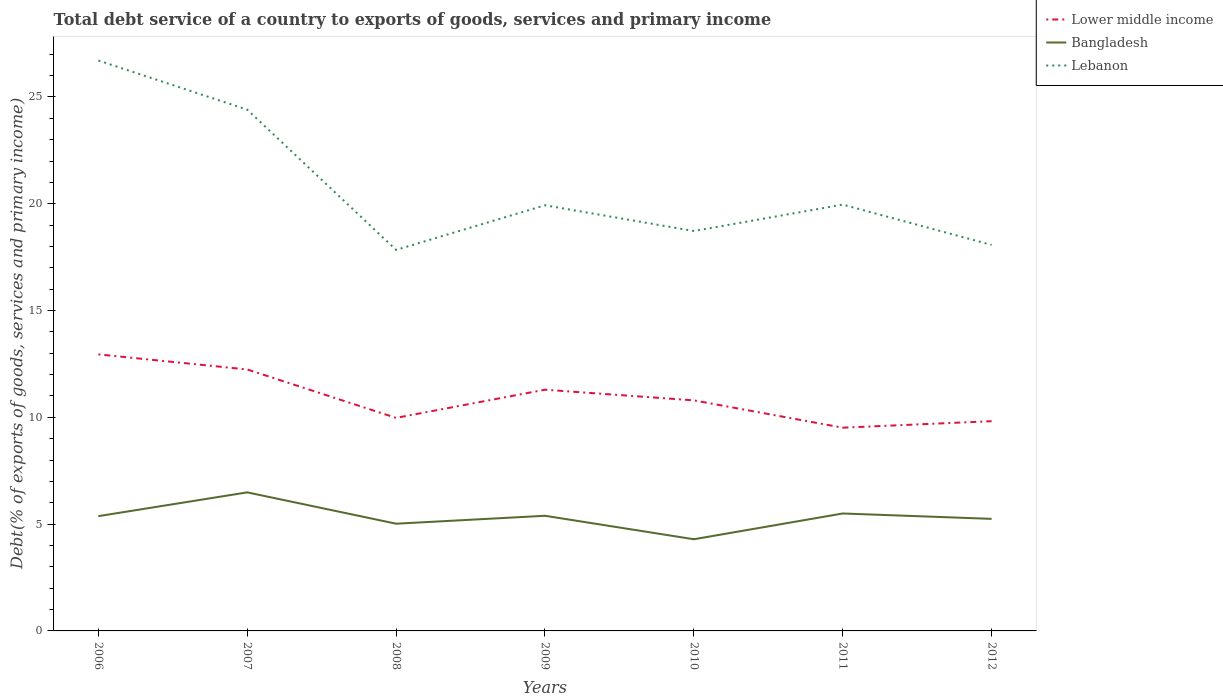Across all years, what is the maximum total debt service in Lebanon?
Make the answer very short. 17.84. In which year was the total debt service in Bangladesh maximum?
Make the answer very short. 2010. What is the total total debt service in Bangladesh in the graph?
Ensure brevity in your answer.  -0.02. What is the difference between the highest and the second highest total debt service in Lower middle income?
Your answer should be very brief. 3.43. Is the total debt service in Bangladesh strictly greater than the total debt service in Lebanon over the years?
Keep it short and to the point. Yes. How many lines are there?
Ensure brevity in your answer.  3. How many years are there in the graph?
Ensure brevity in your answer.  7. Are the values on the major ticks of Y-axis written in scientific E-notation?
Offer a terse response. No. Does the graph contain any zero values?
Offer a terse response. No. Where does the legend appear in the graph?
Your answer should be very brief. Top right. How many legend labels are there?
Make the answer very short. 3. How are the legend labels stacked?
Ensure brevity in your answer.  Vertical. What is the title of the graph?
Keep it short and to the point. Total debt service of a country to exports of goods, services and primary income. What is the label or title of the X-axis?
Your response must be concise. Years. What is the label or title of the Y-axis?
Provide a short and direct response. Debt(% of exports of goods, services and primary income). What is the Debt(% of exports of goods, services and primary income) of Lower middle income in 2006?
Offer a very short reply. 12.95. What is the Debt(% of exports of goods, services and primary income) of Bangladesh in 2006?
Your answer should be very brief. 5.37. What is the Debt(% of exports of goods, services and primary income) in Lebanon in 2006?
Give a very brief answer. 26.71. What is the Debt(% of exports of goods, services and primary income) of Lower middle income in 2007?
Your answer should be very brief. 12.24. What is the Debt(% of exports of goods, services and primary income) of Bangladesh in 2007?
Provide a short and direct response. 6.49. What is the Debt(% of exports of goods, services and primary income) in Lebanon in 2007?
Provide a short and direct response. 24.41. What is the Debt(% of exports of goods, services and primary income) of Lower middle income in 2008?
Ensure brevity in your answer.  9.98. What is the Debt(% of exports of goods, services and primary income) of Bangladesh in 2008?
Your answer should be compact. 5.02. What is the Debt(% of exports of goods, services and primary income) in Lebanon in 2008?
Your response must be concise. 17.84. What is the Debt(% of exports of goods, services and primary income) in Lower middle income in 2009?
Your answer should be very brief. 11.29. What is the Debt(% of exports of goods, services and primary income) in Bangladesh in 2009?
Ensure brevity in your answer.  5.39. What is the Debt(% of exports of goods, services and primary income) in Lebanon in 2009?
Keep it short and to the point. 19.93. What is the Debt(% of exports of goods, services and primary income) in Lower middle income in 2010?
Give a very brief answer. 10.8. What is the Debt(% of exports of goods, services and primary income) of Bangladesh in 2010?
Your answer should be very brief. 4.29. What is the Debt(% of exports of goods, services and primary income) of Lebanon in 2010?
Offer a very short reply. 18.72. What is the Debt(% of exports of goods, services and primary income) in Lower middle income in 2011?
Ensure brevity in your answer.  9.52. What is the Debt(% of exports of goods, services and primary income) in Bangladesh in 2011?
Offer a very short reply. 5.5. What is the Debt(% of exports of goods, services and primary income) in Lebanon in 2011?
Your answer should be compact. 19.96. What is the Debt(% of exports of goods, services and primary income) of Lower middle income in 2012?
Offer a very short reply. 9.82. What is the Debt(% of exports of goods, services and primary income) of Bangladesh in 2012?
Offer a very short reply. 5.25. What is the Debt(% of exports of goods, services and primary income) in Lebanon in 2012?
Offer a very short reply. 18.07. Across all years, what is the maximum Debt(% of exports of goods, services and primary income) in Lower middle income?
Make the answer very short. 12.95. Across all years, what is the maximum Debt(% of exports of goods, services and primary income) in Bangladesh?
Provide a short and direct response. 6.49. Across all years, what is the maximum Debt(% of exports of goods, services and primary income) in Lebanon?
Give a very brief answer. 26.71. Across all years, what is the minimum Debt(% of exports of goods, services and primary income) in Lower middle income?
Your response must be concise. 9.52. Across all years, what is the minimum Debt(% of exports of goods, services and primary income) in Bangladesh?
Provide a short and direct response. 4.29. Across all years, what is the minimum Debt(% of exports of goods, services and primary income) in Lebanon?
Provide a succinct answer. 17.84. What is the total Debt(% of exports of goods, services and primary income) in Lower middle income in the graph?
Your answer should be very brief. 76.59. What is the total Debt(% of exports of goods, services and primary income) in Bangladesh in the graph?
Your response must be concise. 37.31. What is the total Debt(% of exports of goods, services and primary income) in Lebanon in the graph?
Offer a very short reply. 145.64. What is the difference between the Debt(% of exports of goods, services and primary income) of Lower middle income in 2006 and that in 2007?
Your response must be concise. 0.71. What is the difference between the Debt(% of exports of goods, services and primary income) of Bangladesh in 2006 and that in 2007?
Offer a terse response. -1.11. What is the difference between the Debt(% of exports of goods, services and primary income) in Lebanon in 2006 and that in 2007?
Provide a succinct answer. 2.3. What is the difference between the Debt(% of exports of goods, services and primary income) of Lower middle income in 2006 and that in 2008?
Ensure brevity in your answer.  2.97. What is the difference between the Debt(% of exports of goods, services and primary income) in Bangladesh in 2006 and that in 2008?
Your answer should be very brief. 0.35. What is the difference between the Debt(% of exports of goods, services and primary income) in Lebanon in 2006 and that in 2008?
Keep it short and to the point. 8.87. What is the difference between the Debt(% of exports of goods, services and primary income) in Lower middle income in 2006 and that in 2009?
Offer a very short reply. 1.65. What is the difference between the Debt(% of exports of goods, services and primary income) of Bangladesh in 2006 and that in 2009?
Offer a terse response. -0.02. What is the difference between the Debt(% of exports of goods, services and primary income) in Lebanon in 2006 and that in 2009?
Your response must be concise. 6.78. What is the difference between the Debt(% of exports of goods, services and primary income) of Lower middle income in 2006 and that in 2010?
Your answer should be very brief. 2.15. What is the difference between the Debt(% of exports of goods, services and primary income) of Bangladesh in 2006 and that in 2010?
Offer a terse response. 1.08. What is the difference between the Debt(% of exports of goods, services and primary income) in Lebanon in 2006 and that in 2010?
Offer a very short reply. 7.98. What is the difference between the Debt(% of exports of goods, services and primary income) in Lower middle income in 2006 and that in 2011?
Offer a very short reply. 3.43. What is the difference between the Debt(% of exports of goods, services and primary income) in Bangladesh in 2006 and that in 2011?
Ensure brevity in your answer.  -0.12. What is the difference between the Debt(% of exports of goods, services and primary income) in Lebanon in 2006 and that in 2011?
Your answer should be compact. 6.75. What is the difference between the Debt(% of exports of goods, services and primary income) of Lower middle income in 2006 and that in 2012?
Offer a terse response. 3.13. What is the difference between the Debt(% of exports of goods, services and primary income) in Bangladesh in 2006 and that in 2012?
Offer a very short reply. 0.13. What is the difference between the Debt(% of exports of goods, services and primary income) of Lebanon in 2006 and that in 2012?
Offer a very short reply. 8.63. What is the difference between the Debt(% of exports of goods, services and primary income) of Lower middle income in 2007 and that in 2008?
Provide a short and direct response. 2.27. What is the difference between the Debt(% of exports of goods, services and primary income) in Bangladesh in 2007 and that in 2008?
Give a very brief answer. 1.47. What is the difference between the Debt(% of exports of goods, services and primary income) of Lebanon in 2007 and that in 2008?
Keep it short and to the point. 6.57. What is the difference between the Debt(% of exports of goods, services and primary income) in Lower middle income in 2007 and that in 2009?
Your response must be concise. 0.95. What is the difference between the Debt(% of exports of goods, services and primary income) of Bangladesh in 2007 and that in 2009?
Make the answer very short. 1.1. What is the difference between the Debt(% of exports of goods, services and primary income) of Lebanon in 2007 and that in 2009?
Ensure brevity in your answer.  4.48. What is the difference between the Debt(% of exports of goods, services and primary income) in Lower middle income in 2007 and that in 2010?
Offer a terse response. 1.45. What is the difference between the Debt(% of exports of goods, services and primary income) of Bangladesh in 2007 and that in 2010?
Keep it short and to the point. 2.19. What is the difference between the Debt(% of exports of goods, services and primary income) in Lebanon in 2007 and that in 2010?
Your answer should be very brief. 5.68. What is the difference between the Debt(% of exports of goods, services and primary income) in Lower middle income in 2007 and that in 2011?
Give a very brief answer. 2.73. What is the difference between the Debt(% of exports of goods, services and primary income) in Bangladesh in 2007 and that in 2011?
Your answer should be compact. 0.99. What is the difference between the Debt(% of exports of goods, services and primary income) in Lebanon in 2007 and that in 2011?
Provide a succinct answer. 4.45. What is the difference between the Debt(% of exports of goods, services and primary income) of Lower middle income in 2007 and that in 2012?
Offer a terse response. 2.42. What is the difference between the Debt(% of exports of goods, services and primary income) in Bangladesh in 2007 and that in 2012?
Your response must be concise. 1.24. What is the difference between the Debt(% of exports of goods, services and primary income) of Lebanon in 2007 and that in 2012?
Offer a terse response. 6.33. What is the difference between the Debt(% of exports of goods, services and primary income) of Lower middle income in 2008 and that in 2009?
Your response must be concise. -1.32. What is the difference between the Debt(% of exports of goods, services and primary income) in Bangladesh in 2008 and that in 2009?
Offer a very short reply. -0.37. What is the difference between the Debt(% of exports of goods, services and primary income) in Lebanon in 2008 and that in 2009?
Your response must be concise. -2.09. What is the difference between the Debt(% of exports of goods, services and primary income) of Lower middle income in 2008 and that in 2010?
Provide a short and direct response. -0.82. What is the difference between the Debt(% of exports of goods, services and primary income) of Bangladesh in 2008 and that in 2010?
Your answer should be very brief. 0.73. What is the difference between the Debt(% of exports of goods, services and primary income) in Lebanon in 2008 and that in 2010?
Make the answer very short. -0.88. What is the difference between the Debt(% of exports of goods, services and primary income) in Lower middle income in 2008 and that in 2011?
Give a very brief answer. 0.46. What is the difference between the Debt(% of exports of goods, services and primary income) of Bangladesh in 2008 and that in 2011?
Give a very brief answer. -0.48. What is the difference between the Debt(% of exports of goods, services and primary income) of Lebanon in 2008 and that in 2011?
Provide a short and direct response. -2.12. What is the difference between the Debt(% of exports of goods, services and primary income) in Lower middle income in 2008 and that in 2012?
Give a very brief answer. 0.16. What is the difference between the Debt(% of exports of goods, services and primary income) in Bangladesh in 2008 and that in 2012?
Your answer should be compact. -0.23. What is the difference between the Debt(% of exports of goods, services and primary income) in Lebanon in 2008 and that in 2012?
Your answer should be very brief. -0.23. What is the difference between the Debt(% of exports of goods, services and primary income) of Lower middle income in 2009 and that in 2010?
Offer a very short reply. 0.5. What is the difference between the Debt(% of exports of goods, services and primary income) in Bangladesh in 2009 and that in 2010?
Give a very brief answer. 1.1. What is the difference between the Debt(% of exports of goods, services and primary income) of Lebanon in 2009 and that in 2010?
Provide a succinct answer. 1.21. What is the difference between the Debt(% of exports of goods, services and primary income) of Lower middle income in 2009 and that in 2011?
Ensure brevity in your answer.  1.78. What is the difference between the Debt(% of exports of goods, services and primary income) of Bangladesh in 2009 and that in 2011?
Give a very brief answer. -0.11. What is the difference between the Debt(% of exports of goods, services and primary income) of Lebanon in 2009 and that in 2011?
Your answer should be compact. -0.03. What is the difference between the Debt(% of exports of goods, services and primary income) in Lower middle income in 2009 and that in 2012?
Provide a succinct answer. 1.47. What is the difference between the Debt(% of exports of goods, services and primary income) of Bangladesh in 2009 and that in 2012?
Your answer should be very brief. 0.14. What is the difference between the Debt(% of exports of goods, services and primary income) of Lebanon in 2009 and that in 2012?
Keep it short and to the point. 1.86. What is the difference between the Debt(% of exports of goods, services and primary income) of Lower middle income in 2010 and that in 2011?
Give a very brief answer. 1.28. What is the difference between the Debt(% of exports of goods, services and primary income) in Bangladesh in 2010 and that in 2011?
Provide a succinct answer. -1.21. What is the difference between the Debt(% of exports of goods, services and primary income) in Lebanon in 2010 and that in 2011?
Offer a terse response. -1.24. What is the difference between the Debt(% of exports of goods, services and primary income) in Lower middle income in 2010 and that in 2012?
Your answer should be compact. 0.97. What is the difference between the Debt(% of exports of goods, services and primary income) in Bangladesh in 2010 and that in 2012?
Offer a very short reply. -0.95. What is the difference between the Debt(% of exports of goods, services and primary income) in Lebanon in 2010 and that in 2012?
Your answer should be compact. 0.65. What is the difference between the Debt(% of exports of goods, services and primary income) in Lower middle income in 2011 and that in 2012?
Your answer should be very brief. -0.3. What is the difference between the Debt(% of exports of goods, services and primary income) in Bangladesh in 2011 and that in 2012?
Your answer should be very brief. 0.25. What is the difference between the Debt(% of exports of goods, services and primary income) of Lebanon in 2011 and that in 2012?
Your answer should be compact. 1.89. What is the difference between the Debt(% of exports of goods, services and primary income) in Lower middle income in 2006 and the Debt(% of exports of goods, services and primary income) in Bangladesh in 2007?
Offer a very short reply. 6.46. What is the difference between the Debt(% of exports of goods, services and primary income) of Lower middle income in 2006 and the Debt(% of exports of goods, services and primary income) of Lebanon in 2007?
Provide a short and direct response. -11.46. What is the difference between the Debt(% of exports of goods, services and primary income) in Bangladesh in 2006 and the Debt(% of exports of goods, services and primary income) in Lebanon in 2007?
Your answer should be compact. -19.03. What is the difference between the Debt(% of exports of goods, services and primary income) of Lower middle income in 2006 and the Debt(% of exports of goods, services and primary income) of Bangladesh in 2008?
Keep it short and to the point. 7.93. What is the difference between the Debt(% of exports of goods, services and primary income) in Lower middle income in 2006 and the Debt(% of exports of goods, services and primary income) in Lebanon in 2008?
Your answer should be very brief. -4.89. What is the difference between the Debt(% of exports of goods, services and primary income) of Bangladesh in 2006 and the Debt(% of exports of goods, services and primary income) of Lebanon in 2008?
Offer a very short reply. -12.47. What is the difference between the Debt(% of exports of goods, services and primary income) of Lower middle income in 2006 and the Debt(% of exports of goods, services and primary income) of Bangladesh in 2009?
Provide a short and direct response. 7.56. What is the difference between the Debt(% of exports of goods, services and primary income) in Lower middle income in 2006 and the Debt(% of exports of goods, services and primary income) in Lebanon in 2009?
Your response must be concise. -6.98. What is the difference between the Debt(% of exports of goods, services and primary income) in Bangladesh in 2006 and the Debt(% of exports of goods, services and primary income) in Lebanon in 2009?
Your answer should be compact. -14.56. What is the difference between the Debt(% of exports of goods, services and primary income) in Lower middle income in 2006 and the Debt(% of exports of goods, services and primary income) in Bangladesh in 2010?
Give a very brief answer. 8.66. What is the difference between the Debt(% of exports of goods, services and primary income) of Lower middle income in 2006 and the Debt(% of exports of goods, services and primary income) of Lebanon in 2010?
Give a very brief answer. -5.78. What is the difference between the Debt(% of exports of goods, services and primary income) of Bangladesh in 2006 and the Debt(% of exports of goods, services and primary income) of Lebanon in 2010?
Keep it short and to the point. -13.35. What is the difference between the Debt(% of exports of goods, services and primary income) of Lower middle income in 2006 and the Debt(% of exports of goods, services and primary income) of Bangladesh in 2011?
Provide a short and direct response. 7.45. What is the difference between the Debt(% of exports of goods, services and primary income) in Lower middle income in 2006 and the Debt(% of exports of goods, services and primary income) in Lebanon in 2011?
Give a very brief answer. -7.01. What is the difference between the Debt(% of exports of goods, services and primary income) in Bangladesh in 2006 and the Debt(% of exports of goods, services and primary income) in Lebanon in 2011?
Ensure brevity in your answer.  -14.59. What is the difference between the Debt(% of exports of goods, services and primary income) of Lower middle income in 2006 and the Debt(% of exports of goods, services and primary income) of Bangladesh in 2012?
Keep it short and to the point. 7.7. What is the difference between the Debt(% of exports of goods, services and primary income) in Lower middle income in 2006 and the Debt(% of exports of goods, services and primary income) in Lebanon in 2012?
Ensure brevity in your answer.  -5.13. What is the difference between the Debt(% of exports of goods, services and primary income) in Bangladesh in 2006 and the Debt(% of exports of goods, services and primary income) in Lebanon in 2012?
Give a very brief answer. -12.7. What is the difference between the Debt(% of exports of goods, services and primary income) of Lower middle income in 2007 and the Debt(% of exports of goods, services and primary income) of Bangladesh in 2008?
Offer a terse response. 7.22. What is the difference between the Debt(% of exports of goods, services and primary income) of Lower middle income in 2007 and the Debt(% of exports of goods, services and primary income) of Lebanon in 2008?
Your response must be concise. -5.6. What is the difference between the Debt(% of exports of goods, services and primary income) of Bangladesh in 2007 and the Debt(% of exports of goods, services and primary income) of Lebanon in 2008?
Offer a very short reply. -11.35. What is the difference between the Debt(% of exports of goods, services and primary income) in Lower middle income in 2007 and the Debt(% of exports of goods, services and primary income) in Bangladesh in 2009?
Ensure brevity in your answer.  6.85. What is the difference between the Debt(% of exports of goods, services and primary income) of Lower middle income in 2007 and the Debt(% of exports of goods, services and primary income) of Lebanon in 2009?
Offer a terse response. -7.69. What is the difference between the Debt(% of exports of goods, services and primary income) in Bangladesh in 2007 and the Debt(% of exports of goods, services and primary income) in Lebanon in 2009?
Keep it short and to the point. -13.44. What is the difference between the Debt(% of exports of goods, services and primary income) in Lower middle income in 2007 and the Debt(% of exports of goods, services and primary income) in Bangladesh in 2010?
Make the answer very short. 7.95. What is the difference between the Debt(% of exports of goods, services and primary income) of Lower middle income in 2007 and the Debt(% of exports of goods, services and primary income) of Lebanon in 2010?
Your response must be concise. -6.48. What is the difference between the Debt(% of exports of goods, services and primary income) of Bangladesh in 2007 and the Debt(% of exports of goods, services and primary income) of Lebanon in 2010?
Provide a short and direct response. -12.24. What is the difference between the Debt(% of exports of goods, services and primary income) in Lower middle income in 2007 and the Debt(% of exports of goods, services and primary income) in Bangladesh in 2011?
Keep it short and to the point. 6.74. What is the difference between the Debt(% of exports of goods, services and primary income) of Lower middle income in 2007 and the Debt(% of exports of goods, services and primary income) of Lebanon in 2011?
Your response must be concise. -7.72. What is the difference between the Debt(% of exports of goods, services and primary income) of Bangladesh in 2007 and the Debt(% of exports of goods, services and primary income) of Lebanon in 2011?
Offer a very short reply. -13.47. What is the difference between the Debt(% of exports of goods, services and primary income) in Lower middle income in 2007 and the Debt(% of exports of goods, services and primary income) in Bangladesh in 2012?
Offer a terse response. 6.99. What is the difference between the Debt(% of exports of goods, services and primary income) in Lower middle income in 2007 and the Debt(% of exports of goods, services and primary income) in Lebanon in 2012?
Your response must be concise. -5.83. What is the difference between the Debt(% of exports of goods, services and primary income) of Bangladesh in 2007 and the Debt(% of exports of goods, services and primary income) of Lebanon in 2012?
Your answer should be compact. -11.59. What is the difference between the Debt(% of exports of goods, services and primary income) in Lower middle income in 2008 and the Debt(% of exports of goods, services and primary income) in Bangladesh in 2009?
Make the answer very short. 4.58. What is the difference between the Debt(% of exports of goods, services and primary income) of Lower middle income in 2008 and the Debt(% of exports of goods, services and primary income) of Lebanon in 2009?
Provide a short and direct response. -9.96. What is the difference between the Debt(% of exports of goods, services and primary income) in Bangladesh in 2008 and the Debt(% of exports of goods, services and primary income) in Lebanon in 2009?
Provide a succinct answer. -14.91. What is the difference between the Debt(% of exports of goods, services and primary income) of Lower middle income in 2008 and the Debt(% of exports of goods, services and primary income) of Bangladesh in 2010?
Ensure brevity in your answer.  5.68. What is the difference between the Debt(% of exports of goods, services and primary income) in Lower middle income in 2008 and the Debt(% of exports of goods, services and primary income) in Lebanon in 2010?
Ensure brevity in your answer.  -8.75. What is the difference between the Debt(% of exports of goods, services and primary income) in Bangladesh in 2008 and the Debt(% of exports of goods, services and primary income) in Lebanon in 2010?
Your answer should be compact. -13.7. What is the difference between the Debt(% of exports of goods, services and primary income) of Lower middle income in 2008 and the Debt(% of exports of goods, services and primary income) of Bangladesh in 2011?
Your answer should be very brief. 4.48. What is the difference between the Debt(% of exports of goods, services and primary income) in Lower middle income in 2008 and the Debt(% of exports of goods, services and primary income) in Lebanon in 2011?
Ensure brevity in your answer.  -9.99. What is the difference between the Debt(% of exports of goods, services and primary income) in Bangladesh in 2008 and the Debt(% of exports of goods, services and primary income) in Lebanon in 2011?
Make the answer very short. -14.94. What is the difference between the Debt(% of exports of goods, services and primary income) in Lower middle income in 2008 and the Debt(% of exports of goods, services and primary income) in Bangladesh in 2012?
Offer a terse response. 4.73. What is the difference between the Debt(% of exports of goods, services and primary income) of Lower middle income in 2008 and the Debt(% of exports of goods, services and primary income) of Lebanon in 2012?
Keep it short and to the point. -8.1. What is the difference between the Debt(% of exports of goods, services and primary income) of Bangladesh in 2008 and the Debt(% of exports of goods, services and primary income) of Lebanon in 2012?
Ensure brevity in your answer.  -13.05. What is the difference between the Debt(% of exports of goods, services and primary income) in Lower middle income in 2009 and the Debt(% of exports of goods, services and primary income) in Bangladesh in 2010?
Give a very brief answer. 7. What is the difference between the Debt(% of exports of goods, services and primary income) in Lower middle income in 2009 and the Debt(% of exports of goods, services and primary income) in Lebanon in 2010?
Provide a succinct answer. -7.43. What is the difference between the Debt(% of exports of goods, services and primary income) of Bangladesh in 2009 and the Debt(% of exports of goods, services and primary income) of Lebanon in 2010?
Keep it short and to the point. -13.33. What is the difference between the Debt(% of exports of goods, services and primary income) in Lower middle income in 2009 and the Debt(% of exports of goods, services and primary income) in Bangladesh in 2011?
Your answer should be compact. 5.8. What is the difference between the Debt(% of exports of goods, services and primary income) in Lower middle income in 2009 and the Debt(% of exports of goods, services and primary income) in Lebanon in 2011?
Your response must be concise. -8.67. What is the difference between the Debt(% of exports of goods, services and primary income) in Bangladesh in 2009 and the Debt(% of exports of goods, services and primary income) in Lebanon in 2011?
Offer a very short reply. -14.57. What is the difference between the Debt(% of exports of goods, services and primary income) in Lower middle income in 2009 and the Debt(% of exports of goods, services and primary income) in Bangladesh in 2012?
Give a very brief answer. 6.05. What is the difference between the Debt(% of exports of goods, services and primary income) in Lower middle income in 2009 and the Debt(% of exports of goods, services and primary income) in Lebanon in 2012?
Make the answer very short. -6.78. What is the difference between the Debt(% of exports of goods, services and primary income) in Bangladesh in 2009 and the Debt(% of exports of goods, services and primary income) in Lebanon in 2012?
Keep it short and to the point. -12.68. What is the difference between the Debt(% of exports of goods, services and primary income) in Lower middle income in 2010 and the Debt(% of exports of goods, services and primary income) in Bangladesh in 2011?
Ensure brevity in your answer.  5.3. What is the difference between the Debt(% of exports of goods, services and primary income) in Lower middle income in 2010 and the Debt(% of exports of goods, services and primary income) in Lebanon in 2011?
Ensure brevity in your answer.  -9.17. What is the difference between the Debt(% of exports of goods, services and primary income) of Bangladesh in 2010 and the Debt(% of exports of goods, services and primary income) of Lebanon in 2011?
Provide a succinct answer. -15.67. What is the difference between the Debt(% of exports of goods, services and primary income) in Lower middle income in 2010 and the Debt(% of exports of goods, services and primary income) in Bangladesh in 2012?
Your response must be concise. 5.55. What is the difference between the Debt(% of exports of goods, services and primary income) of Lower middle income in 2010 and the Debt(% of exports of goods, services and primary income) of Lebanon in 2012?
Keep it short and to the point. -7.28. What is the difference between the Debt(% of exports of goods, services and primary income) of Bangladesh in 2010 and the Debt(% of exports of goods, services and primary income) of Lebanon in 2012?
Give a very brief answer. -13.78. What is the difference between the Debt(% of exports of goods, services and primary income) in Lower middle income in 2011 and the Debt(% of exports of goods, services and primary income) in Bangladesh in 2012?
Your response must be concise. 4.27. What is the difference between the Debt(% of exports of goods, services and primary income) in Lower middle income in 2011 and the Debt(% of exports of goods, services and primary income) in Lebanon in 2012?
Keep it short and to the point. -8.56. What is the difference between the Debt(% of exports of goods, services and primary income) of Bangladesh in 2011 and the Debt(% of exports of goods, services and primary income) of Lebanon in 2012?
Provide a succinct answer. -12.57. What is the average Debt(% of exports of goods, services and primary income) in Lower middle income per year?
Offer a very short reply. 10.94. What is the average Debt(% of exports of goods, services and primary income) in Bangladesh per year?
Provide a short and direct response. 5.33. What is the average Debt(% of exports of goods, services and primary income) of Lebanon per year?
Make the answer very short. 20.81. In the year 2006, what is the difference between the Debt(% of exports of goods, services and primary income) in Lower middle income and Debt(% of exports of goods, services and primary income) in Bangladesh?
Your answer should be very brief. 7.57. In the year 2006, what is the difference between the Debt(% of exports of goods, services and primary income) of Lower middle income and Debt(% of exports of goods, services and primary income) of Lebanon?
Your answer should be compact. -13.76. In the year 2006, what is the difference between the Debt(% of exports of goods, services and primary income) of Bangladesh and Debt(% of exports of goods, services and primary income) of Lebanon?
Your answer should be very brief. -21.33. In the year 2007, what is the difference between the Debt(% of exports of goods, services and primary income) in Lower middle income and Debt(% of exports of goods, services and primary income) in Bangladesh?
Make the answer very short. 5.75. In the year 2007, what is the difference between the Debt(% of exports of goods, services and primary income) of Lower middle income and Debt(% of exports of goods, services and primary income) of Lebanon?
Offer a terse response. -12.16. In the year 2007, what is the difference between the Debt(% of exports of goods, services and primary income) in Bangladesh and Debt(% of exports of goods, services and primary income) in Lebanon?
Your answer should be very brief. -17.92. In the year 2008, what is the difference between the Debt(% of exports of goods, services and primary income) in Lower middle income and Debt(% of exports of goods, services and primary income) in Bangladesh?
Provide a short and direct response. 4.96. In the year 2008, what is the difference between the Debt(% of exports of goods, services and primary income) in Lower middle income and Debt(% of exports of goods, services and primary income) in Lebanon?
Ensure brevity in your answer.  -7.86. In the year 2008, what is the difference between the Debt(% of exports of goods, services and primary income) of Bangladesh and Debt(% of exports of goods, services and primary income) of Lebanon?
Make the answer very short. -12.82. In the year 2009, what is the difference between the Debt(% of exports of goods, services and primary income) in Lower middle income and Debt(% of exports of goods, services and primary income) in Bangladesh?
Make the answer very short. 5.9. In the year 2009, what is the difference between the Debt(% of exports of goods, services and primary income) of Lower middle income and Debt(% of exports of goods, services and primary income) of Lebanon?
Ensure brevity in your answer.  -8.64. In the year 2009, what is the difference between the Debt(% of exports of goods, services and primary income) of Bangladesh and Debt(% of exports of goods, services and primary income) of Lebanon?
Make the answer very short. -14.54. In the year 2010, what is the difference between the Debt(% of exports of goods, services and primary income) in Lower middle income and Debt(% of exports of goods, services and primary income) in Bangladesh?
Keep it short and to the point. 6.5. In the year 2010, what is the difference between the Debt(% of exports of goods, services and primary income) in Lower middle income and Debt(% of exports of goods, services and primary income) in Lebanon?
Keep it short and to the point. -7.93. In the year 2010, what is the difference between the Debt(% of exports of goods, services and primary income) of Bangladesh and Debt(% of exports of goods, services and primary income) of Lebanon?
Offer a terse response. -14.43. In the year 2011, what is the difference between the Debt(% of exports of goods, services and primary income) in Lower middle income and Debt(% of exports of goods, services and primary income) in Bangladesh?
Offer a very short reply. 4.02. In the year 2011, what is the difference between the Debt(% of exports of goods, services and primary income) of Lower middle income and Debt(% of exports of goods, services and primary income) of Lebanon?
Ensure brevity in your answer.  -10.45. In the year 2011, what is the difference between the Debt(% of exports of goods, services and primary income) in Bangladesh and Debt(% of exports of goods, services and primary income) in Lebanon?
Ensure brevity in your answer.  -14.46. In the year 2012, what is the difference between the Debt(% of exports of goods, services and primary income) of Lower middle income and Debt(% of exports of goods, services and primary income) of Bangladesh?
Provide a succinct answer. 4.57. In the year 2012, what is the difference between the Debt(% of exports of goods, services and primary income) of Lower middle income and Debt(% of exports of goods, services and primary income) of Lebanon?
Provide a short and direct response. -8.25. In the year 2012, what is the difference between the Debt(% of exports of goods, services and primary income) in Bangladesh and Debt(% of exports of goods, services and primary income) in Lebanon?
Offer a very short reply. -12.83. What is the ratio of the Debt(% of exports of goods, services and primary income) in Lower middle income in 2006 to that in 2007?
Your answer should be compact. 1.06. What is the ratio of the Debt(% of exports of goods, services and primary income) of Bangladesh in 2006 to that in 2007?
Make the answer very short. 0.83. What is the ratio of the Debt(% of exports of goods, services and primary income) in Lebanon in 2006 to that in 2007?
Ensure brevity in your answer.  1.09. What is the ratio of the Debt(% of exports of goods, services and primary income) in Lower middle income in 2006 to that in 2008?
Make the answer very short. 1.3. What is the ratio of the Debt(% of exports of goods, services and primary income) of Bangladesh in 2006 to that in 2008?
Keep it short and to the point. 1.07. What is the ratio of the Debt(% of exports of goods, services and primary income) in Lebanon in 2006 to that in 2008?
Keep it short and to the point. 1.5. What is the ratio of the Debt(% of exports of goods, services and primary income) of Lower middle income in 2006 to that in 2009?
Your response must be concise. 1.15. What is the ratio of the Debt(% of exports of goods, services and primary income) of Lebanon in 2006 to that in 2009?
Provide a short and direct response. 1.34. What is the ratio of the Debt(% of exports of goods, services and primary income) of Lower middle income in 2006 to that in 2010?
Your answer should be very brief. 1.2. What is the ratio of the Debt(% of exports of goods, services and primary income) in Bangladesh in 2006 to that in 2010?
Make the answer very short. 1.25. What is the ratio of the Debt(% of exports of goods, services and primary income) of Lebanon in 2006 to that in 2010?
Offer a terse response. 1.43. What is the ratio of the Debt(% of exports of goods, services and primary income) in Lower middle income in 2006 to that in 2011?
Give a very brief answer. 1.36. What is the ratio of the Debt(% of exports of goods, services and primary income) in Bangladesh in 2006 to that in 2011?
Your answer should be compact. 0.98. What is the ratio of the Debt(% of exports of goods, services and primary income) in Lebanon in 2006 to that in 2011?
Your response must be concise. 1.34. What is the ratio of the Debt(% of exports of goods, services and primary income) in Lower middle income in 2006 to that in 2012?
Give a very brief answer. 1.32. What is the ratio of the Debt(% of exports of goods, services and primary income) of Bangladesh in 2006 to that in 2012?
Keep it short and to the point. 1.02. What is the ratio of the Debt(% of exports of goods, services and primary income) in Lebanon in 2006 to that in 2012?
Provide a succinct answer. 1.48. What is the ratio of the Debt(% of exports of goods, services and primary income) in Lower middle income in 2007 to that in 2008?
Provide a short and direct response. 1.23. What is the ratio of the Debt(% of exports of goods, services and primary income) in Bangladesh in 2007 to that in 2008?
Your answer should be very brief. 1.29. What is the ratio of the Debt(% of exports of goods, services and primary income) of Lebanon in 2007 to that in 2008?
Offer a very short reply. 1.37. What is the ratio of the Debt(% of exports of goods, services and primary income) of Lower middle income in 2007 to that in 2009?
Offer a very short reply. 1.08. What is the ratio of the Debt(% of exports of goods, services and primary income) in Bangladesh in 2007 to that in 2009?
Offer a very short reply. 1.2. What is the ratio of the Debt(% of exports of goods, services and primary income) of Lebanon in 2007 to that in 2009?
Provide a short and direct response. 1.22. What is the ratio of the Debt(% of exports of goods, services and primary income) in Lower middle income in 2007 to that in 2010?
Your answer should be very brief. 1.13. What is the ratio of the Debt(% of exports of goods, services and primary income) of Bangladesh in 2007 to that in 2010?
Make the answer very short. 1.51. What is the ratio of the Debt(% of exports of goods, services and primary income) in Lebanon in 2007 to that in 2010?
Your answer should be compact. 1.3. What is the ratio of the Debt(% of exports of goods, services and primary income) of Lower middle income in 2007 to that in 2011?
Provide a succinct answer. 1.29. What is the ratio of the Debt(% of exports of goods, services and primary income) in Bangladesh in 2007 to that in 2011?
Your answer should be compact. 1.18. What is the ratio of the Debt(% of exports of goods, services and primary income) of Lebanon in 2007 to that in 2011?
Offer a very short reply. 1.22. What is the ratio of the Debt(% of exports of goods, services and primary income) of Lower middle income in 2007 to that in 2012?
Ensure brevity in your answer.  1.25. What is the ratio of the Debt(% of exports of goods, services and primary income) in Bangladesh in 2007 to that in 2012?
Keep it short and to the point. 1.24. What is the ratio of the Debt(% of exports of goods, services and primary income) in Lebanon in 2007 to that in 2012?
Ensure brevity in your answer.  1.35. What is the ratio of the Debt(% of exports of goods, services and primary income) of Lower middle income in 2008 to that in 2009?
Offer a terse response. 0.88. What is the ratio of the Debt(% of exports of goods, services and primary income) in Bangladesh in 2008 to that in 2009?
Your answer should be compact. 0.93. What is the ratio of the Debt(% of exports of goods, services and primary income) in Lebanon in 2008 to that in 2009?
Keep it short and to the point. 0.9. What is the ratio of the Debt(% of exports of goods, services and primary income) of Lower middle income in 2008 to that in 2010?
Ensure brevity in your answer.  0.92. What is the ratio of the Debt(% of exports of goods, services and primary income) in Bangladesh in 2008 to that in 2010?
Make the answer very short. 1.17. What is the ratio of the Debt(% of exports of goods, services and primary income) in Lebanon in 2008 to that in 2010?
Keep it short and to the point. 0.95. What is the ratio of the Debt(% of exports of goods, services and primary income) of Lower middle income in 2008 to that in 2011?
Provide a succinct answer. 1.05. What is the ratio of the Debt(% of exports of goods, services and primary income) of Bangladesh in 2008 to that in 2011?
Keep it short and to the point. 0.91. What is the ratio of the Debt(% of exports of goods, services and primary income) of Lebanon in 2008 to that in 2011?
Give a very brief answer. 0.89. What is the ratio of the Debt(% of exports of goods, services and primary income) of Lower middle income in 2008 to that in 2012?
Your response must be concise. 1.02. What is the ratio of the Debt(% of exports of goods, services and primary income) of Bangladesh in 2008 to that in 2012?
Your answer should be very brief. 0.96. What is the ratio of the Debt(% of exports of goods, services and primary income) of Lebanon in 2008 to that in 2012?
Provide a succinct answer. 0.99. What is the ratio of the Debt(% of exports of goods, services and primary income) in Lower middle income in 2009 to that in 2010?
Give a very brief answer. 1.05. What is the ratio of the Debt(% of exports of goods, services and primary income) of Bangladesh in 2009 to that in 2010?
Your answer should be compact. 1.26. What is the ratio of the Debt(% of exports of goods, services and primary income) in Lebanon in 2009 to that in 2010?
Give a very brief answer. 1.06. What is the ratio of the Debt(% of exports of goods, services and primary income) of Lower middle income in 2009 to that in 2011?
Provide a short and direct response. 1.19. What is the ratio of the Debt(% of exports of goods, services and primary income) in Bangladesh in 2009 to that in 2011?
Provide a succinct answer. 0.98. What is the ratio of the Debt(% of exports of goods, services and primary income) in Lower middle income in 2009 to that in 2012?
Ensure brevity in your answer.  1.15. What is the ratio of the Debt(% of exports of goods, services and primary income) of Bangladesh in 2009 to that in 2012?
Offer a terse response. 1.03. What is the ratio of the Debt(% of exports of goods, services and primary income) in Lebanon in 2009 to that in 2012?
Your answer should be compact. 1.1. What is the ratio of the Debt(% of exports of goods, services and primary income) of Lower middle income in 2010 to that in 2011?
Your answer should be compact. 1.13. What is the ratio of the Debt(% of exports of goods, services and primary income) of Bangladesh in 2010 to that in 2011?
Your response must be concise. 0.78. What is the ratio of the Debt(% of exports of goods, services and primary income) in Lebanon in 2010 to that in 2011?
Your response must be concise. 0.94. What is the ratio of the Debt(% of exports of goods, services and primary income) in Lower middle income in 2010 to that in 2012?
Make the answer very short. 1.1. What is the ratio of the Debt(% of exports of goods, services and primary income) in Bangladesh in 2010 to that in 2012?
Keep it short and to the point. 0.82. What is the ratio of the Debt(% of exports of goods, services and primary income) of Lebanon in 2010 to that in 2012?
Make the answer very short. 1.04. What is the ratio of the Debt(% of exports of goods, services and primary income) of Bangladesh in 2011 to that in 2012?
Offer a very short reply. 1.05. What is the ratio of the Debt(% of exports of goods, services and primary income) in Lebanon in 2011 to that in 2012?
Offer a very short reply. 1.1. What is the difference between the highest and the second highest Debt(% of exports of goods, services and primary income) of Lower middle income?
Your answer should be very brief. 0.71. What is the difference between the highest and the second highest Debt(% of exports of goods, services and primary income) in Bangladesh?
Offer a terse response. 0.99. What is the difference between the highest and the second highest Debt(% of exports of goods, services and primary income) in Lebanon?
Your answer should be compact. 2.3. What is the difference between the highest and the lowest Debt(% of exports of goods, services and primary income) in Lower middle income?
Your answer should be compact. 3.43. What is the difference between the highest and the lowest Debt(% of exports of goods, services and primary income) in Bangladesh?
Provide a short and direct response. 2.19. What is the difference between the highest and the lowest Debt(% of exports of goods, services and primary income) of Lebanon?
Give a very brief answer. 8.87. 